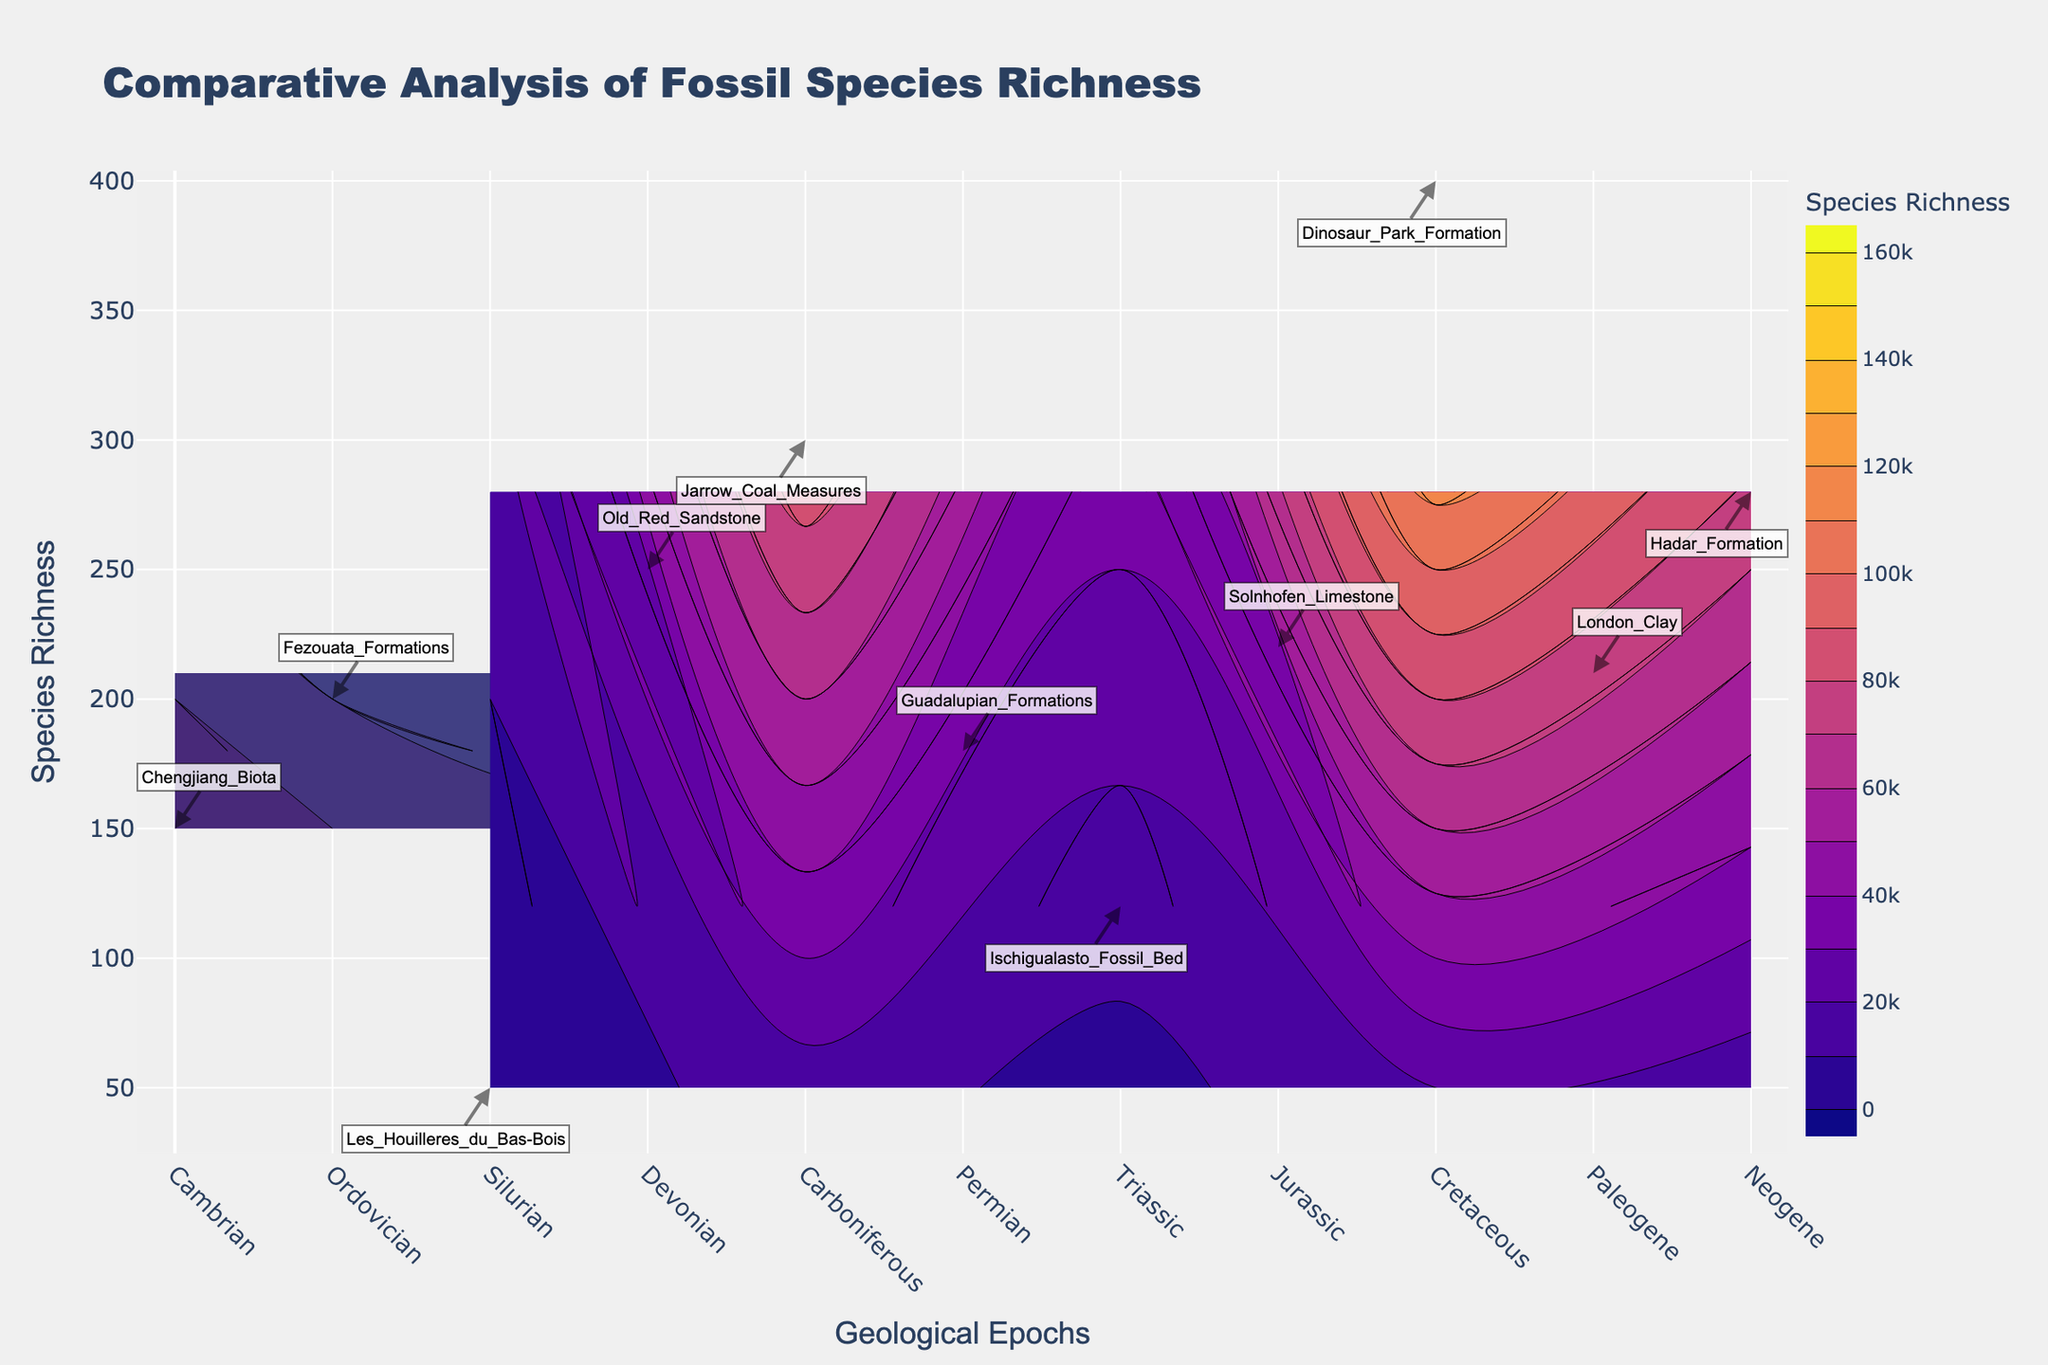What is the title of the figure? The title is usually displayed prominently at the top of the figure. Here, it reads "Comparative Analysis of Fossil Species Richness".
Answer: Comparative Analysis of Fossil Species Richness What are the colors used to represent marine and terrestrial environments? The color representing marine environments uses the 'Viridis' scale, typically shades of green and blue. The terrestrial environments use the 'Plasma' scale, which is usually shades of purple and orange.
Answer: Green/Blue for Marine and Purple/Orange for Terrestrial Which geological epoch has the highest species richness in the terrestrial environment? The species richness for terrestrial environments is represented by the y-axis values. The peak value for terrestrial data is noticed in the "Cretaceous" epoch with a value of 400.
Answer: Cretaceous How does the species richness in the Jurassic epoch compare between marine and terrestrial environments? In the Jurassic epoch, marine species richness is at 220. Since there is only marine data for Jurassic observable from the labels and no terrestrial data point for comparison. This means richness is only available for marine during Jurassic.
Answer: Only marine data available: 220 What is the trend of species richness in marine environments over different epochs? By observing the marine contour plot across epochs from Cambrian to Paleogene, the richness initially spikes in the Ordovician (200), peaks further in the Devonian (250), dips in the Permian (180), rises again in the Jurassic (220), and maintains around 210 in the Paleogene.
Answer: Fluctuating with highs in Devonian (250) and Jurassic (220) Identify the fossil site associated with the highest marine species richness. What epoch is it from? The fossil site annotation at the highest point on the marine contour indicates "Old_Red_Sandstone" associated with the Devonian epoch (250 species richness).
Answer: Old_Red_Sandstone, Devonian Which epoch shows a significant increase in terrestrial species richness compared to its previous epoch? Examining species richness values for terrestrial environments shows a significant jump from the Silurian epoch (50) to the Carboniferous epoch (300) indicating a vast increase between these periods.
Answer: Carboniferous How are the color bar scales different for marine and terrestrial environments in this figure? The color bar scales for marine extend to 250,000, whereas for the terrestrial it only goes up to 160,000, reflecting different scaling ranges for species richness.
Answer: Marine: 250,000; Terrestrial: 160,000 What annotations are present in the Cambrian epoch for the marine environment? An annotation is found in the contour for marine environments within the Cambrian epoch. The label reads "Chengjiang_Biota" at a species richness of 150.
Answer: Chengjiang_Biota 